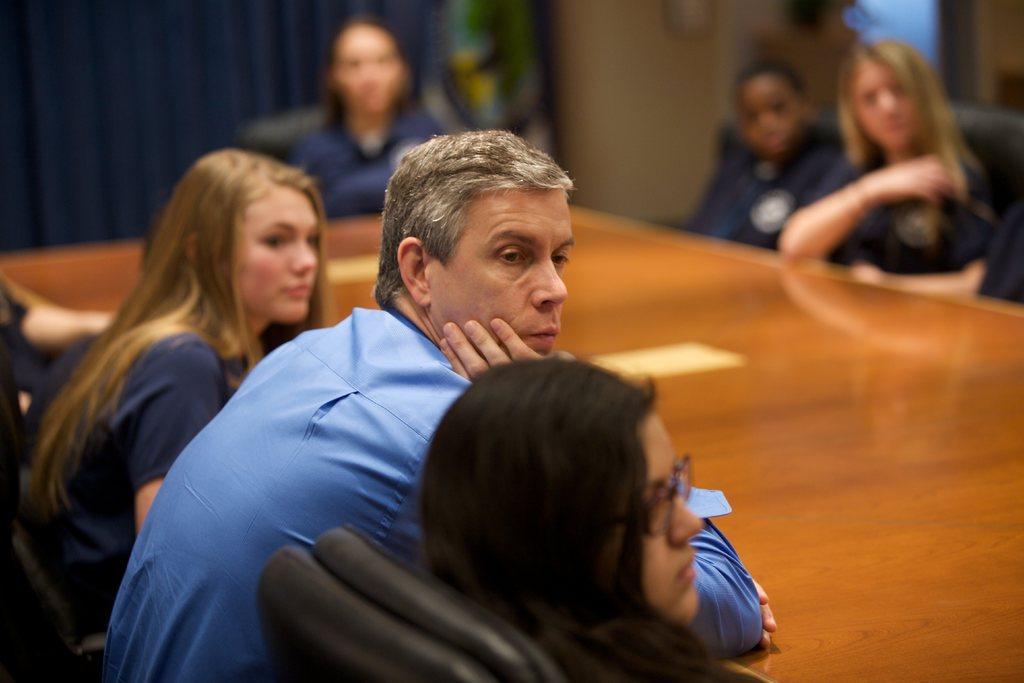Describe this image in one or two sentences. In the center of the image we can see a table. On the table we can see the papers. Beside a table we can see some people are sitting on the chairs. At the top of the image we can see the curtain, wall. 